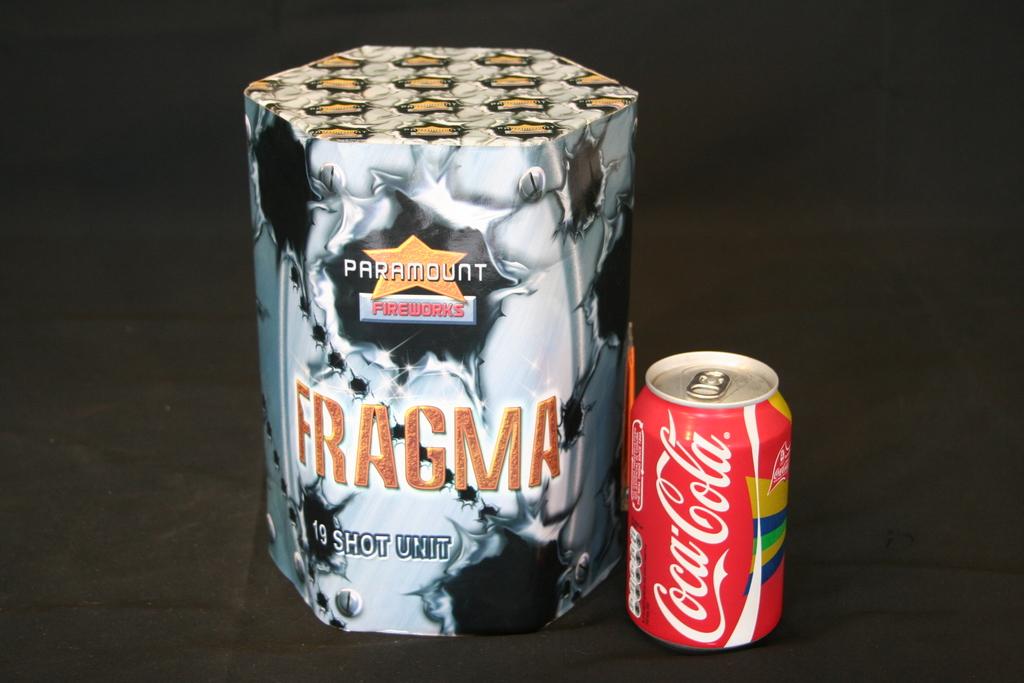What kind of soda is in the can?
Your answer should be very brief. Coca cola. 